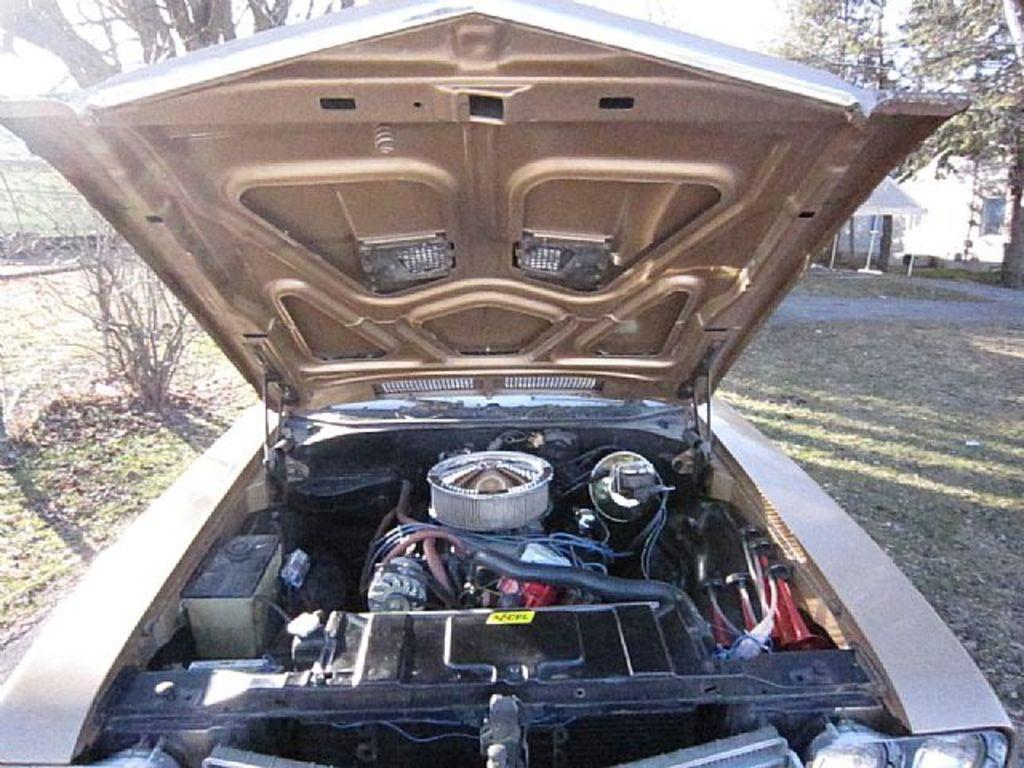What type of accessory is present in the image? There is a bonnet in the image. What mechanical component is visible in the image? There is an engine in the image. What type of electrical components can be seen in the image? There are wires in the image. What other vehicle parts are present in the image? There are other vehicle parts in the image. What can be seen in the background of the image? There are trees, houses, and grass in the background of the image. Can you tell me how many boats are visible in the image? There are no boats present in the image. What type of flock is flying over the trees in the background? There is no flock of birds or animals visible in the image. 